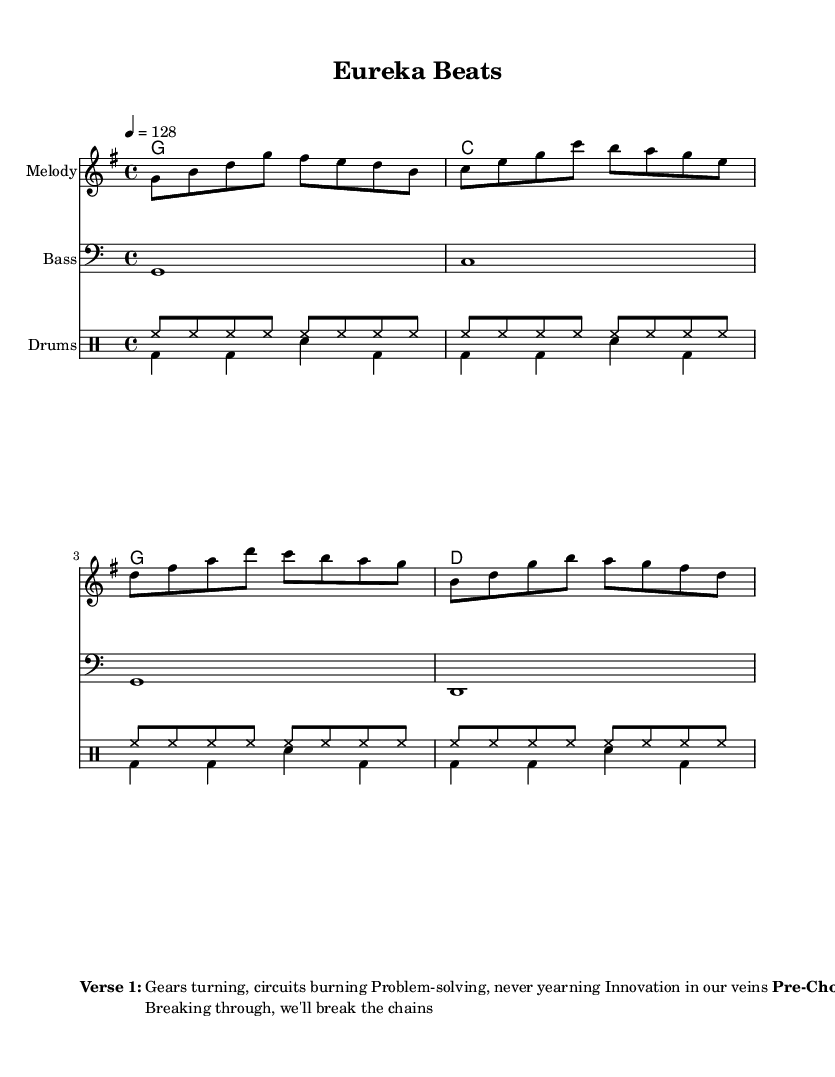What is the key signature of this music? The key signature is G major, which has one sharp (F#). This can be identified from the key signature mark at the beginning of the staff.
Answer: G major What is the time signature of this piece? The time signature is 4/4, which is indicated at the beginning of the score. This means there are four beats in a measure, and the quarter note gets one beat.
Answer: 4/4 What is the tempo marking given? The tempo marking is 128 beats per minute, indicated by "4 = 128" at the top of the score. This indicates how fast the piece should be played.
Answer: 128 What instruments are included in this score? The instruments included are Melody, Bass, and Drums. This can be determined by the labels on each staff that display the names of the instruments.
Answer: Melody, Bass, Drums How many measures are in the melody? The melody contains four measures, as seen by the grouping of notes and the corresponding bar lines that segment them into four distinct parts.
Answer: 4 What subject matter is celebrated in the lyrics? The lyrics celebrate scientific breakthroughs and problem-solving, as seen in the words "Eureka moment" and "scientific breakthrough" in the chorus and verses.
Answer: Scientific breakthroughs What is the repeated phrase in the chorus? The repeated phrase in the chorus is "Eureka beats, everything's alright." This line not only encapsulates the theme of the song but is a clear memorable hook.
Answer: Eureka beats, everything's alright 